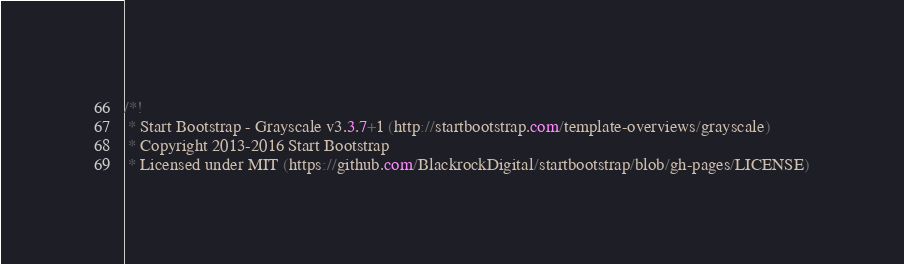Convert code to text. <code><loc_0><loc_0><loc_500><loc_500><_CSS_>/*!
 * Start Bootstrap - Grayscale v3.3.7+1 (http://startbootstrap.com/template-overviews/grayscale)
 * Copyright 2013-2016 Start Bootstrap
 * Licensed under MIT (https://github.com/BlackrockDigital/startbootstrap/blob/gh-pages/LICENSE)</code> 